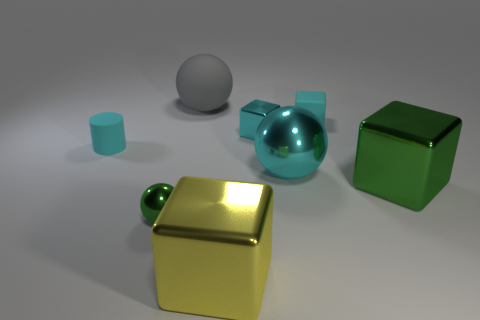There is a shiny sphere that is the same color as the cylinder; what is its size?
Your answer should be very brief. Large. Is there a small block that has the same material as the green ball?
Ensure brevity in your answer.  Yes. How many objects are big things that are to the right of the cyan metallic block or shiny things behind the tiny metal ball?
Your answer should be very brief. 3. There is a yellow thing; is it the same shape as the small matte object behind the cylinder?
Your answer should be compact. Yes. How many other objects are there of the same shape as the big yellow metal thing?
Your answer should be compact. 3. How many objects are tiny matte cubes or green metallic blocks?
Your answer should be very brief. 2. Is the color of the rubber cylinder the same as the matte cube?
Your answer should be very brief. Yes. What is the shape of the tiny matte object that is to the right of the large thing behind the big cyan object?
Offer a very short reply. Cube. Are there fewer cyan cubes than cyan objects?
Keep it short and to the point. Yes. There is a metallic cube that is both in front of the large cyan thing and behind the yellow metallic thing; what size is it?
Your answer should be compact. Large. 